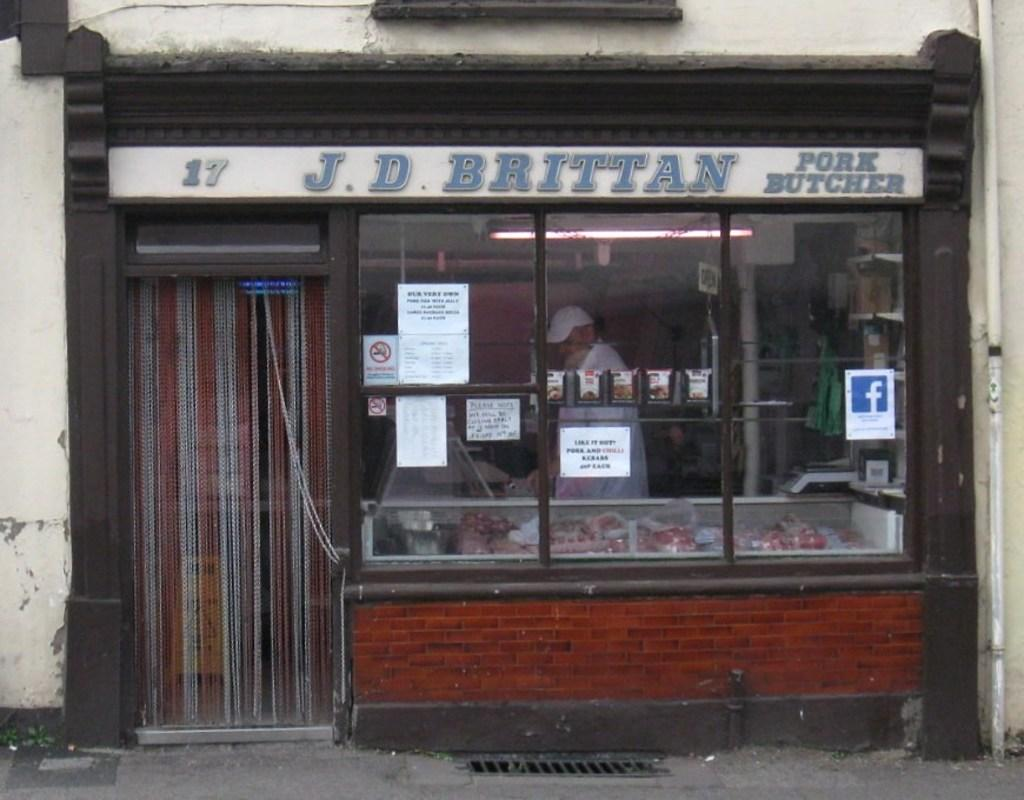What type of establishment is in the middle of the image? There is a shop in the middle of the image. What can be seen on the walls or surfaces inside the shop? There are posters and text visible in the shop. Who is present inside the shop? There are people in the shop. What items are available for purchase in the shop? There are items in the shop. How can customers enter or exit the shop? There is a door in the shop. What type of window treatment is present in the shop? There is a curtain in the shop. What structural element can be seen in the shop? There is a wall in the shop. What type of plumbing fixture is visible in the shop? There is a pipe in the shop. What type of station is depicted in the image? There is no train station or any other type of station present in the image; it features a shop. How much salt is visible in the image? There is no salt present in the image. 